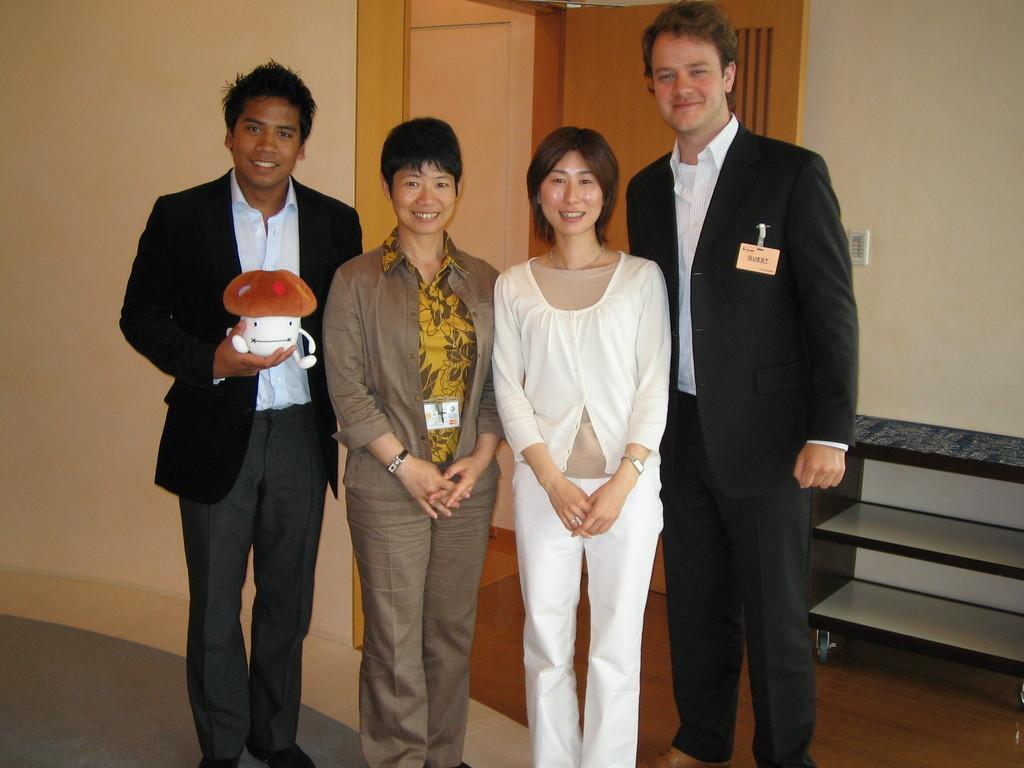Please provide a concise description of this image. This picture looks like a inner view of a room and I can see few people standing and a man holding a toy his hand and I can see couple of them were ID cards and I can see a door in the back and I can see shelves. 